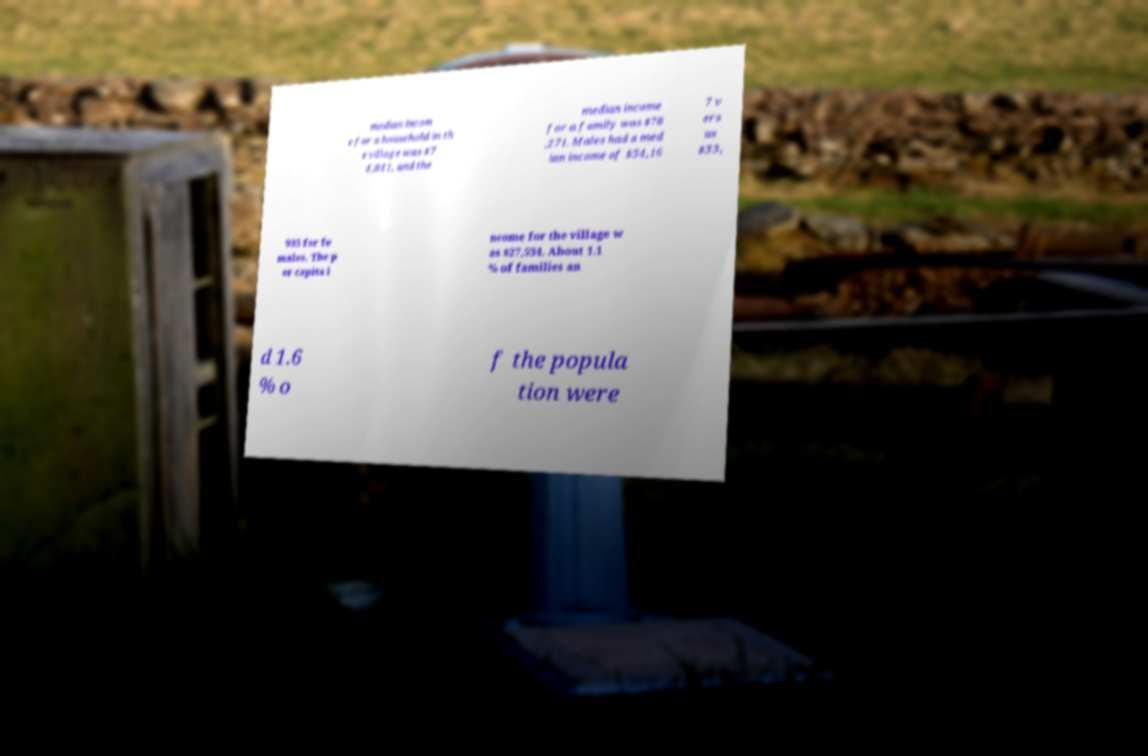There's text embedded in this image that I need extracted. Can you transcribe it verbatim? median incom e for a household in th e village was $7 4,841, and the median income for a family was $78 ,271. Males had a med ian income of $54,16 7 v ers us $33, 935 for fe males. The p er capita i ncome for the village w as $27,534. About 1.1 % of families an d 1.6 % o f the popula tion were 